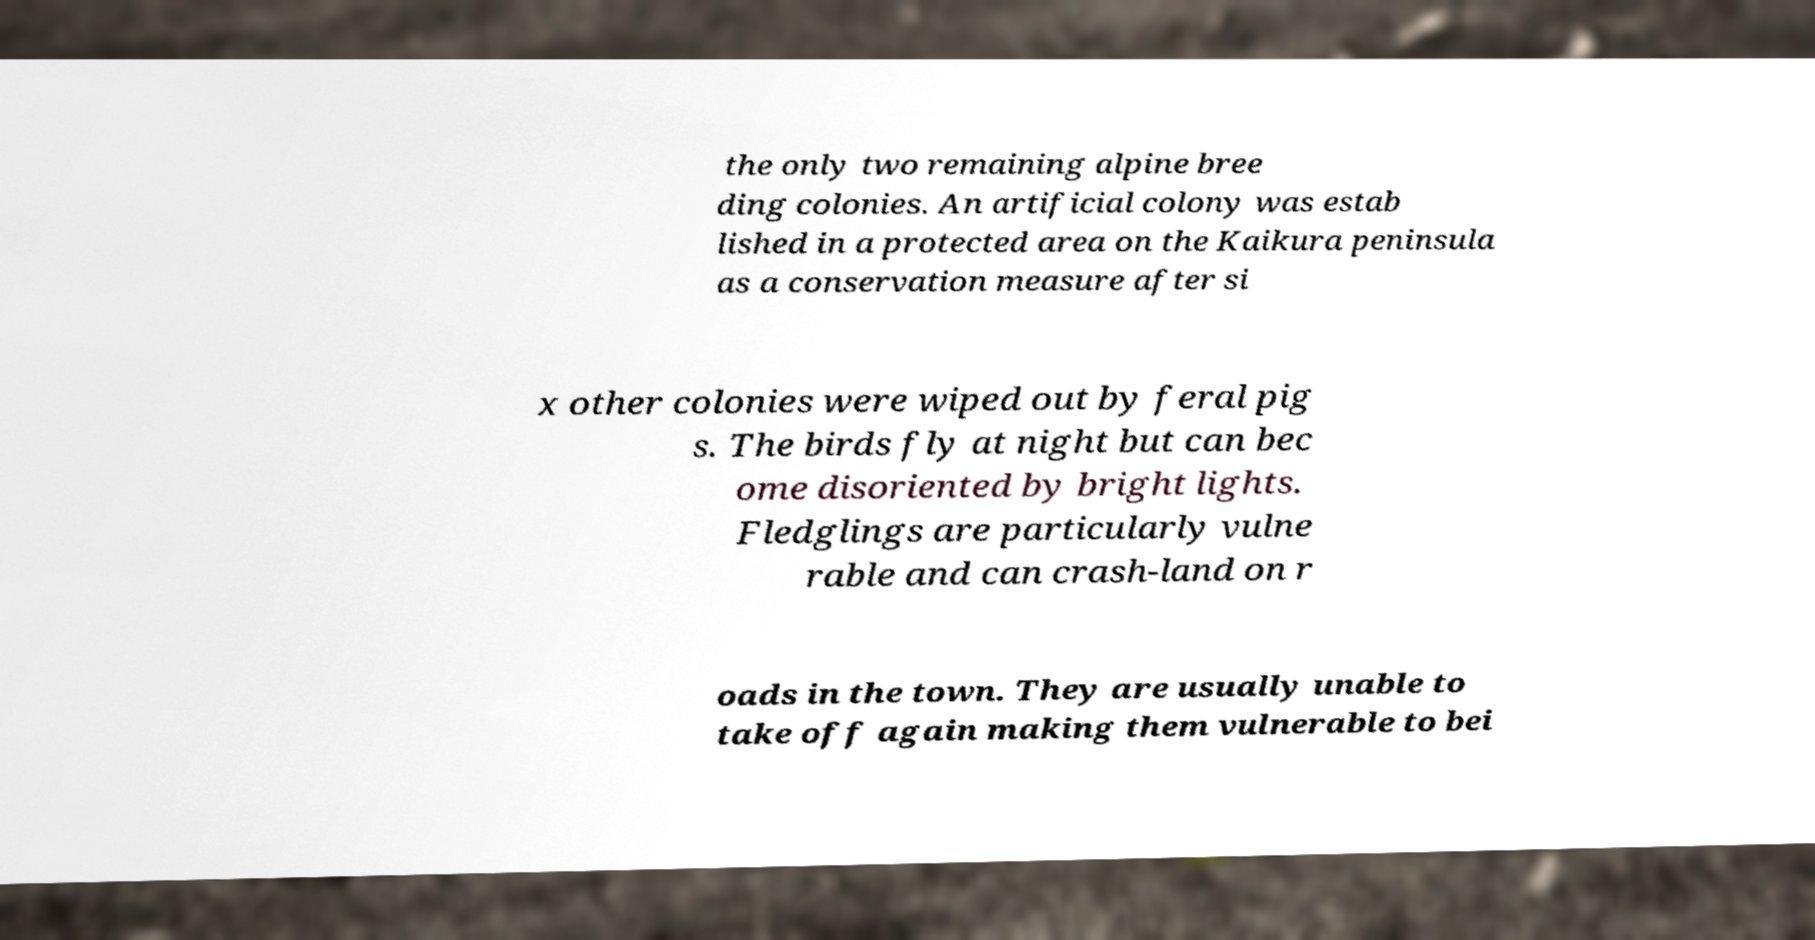Please read and relay the text visible in this image. What does it say? the only two remaining alpine bree ding colonies. An artificial colony was estab lished in a protected area on the Kaikura peninsula as a conservation measure after si x other colonies were wiped out by feral pig s. The birds fly at night but can bec ome disoriented by bright lights. Fledglings are particularly vulne rable and can crash-land on r oads in the town. They are usually unable to take off again making them vulnerable to bei 